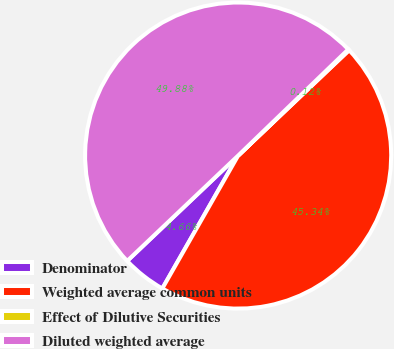Convert chart. <chart><loc_0><loc_0><loc_500><loc_500><pie_chart><fcel>Denominator<fcel>Weighted average common units<fcel>Effect of Dilutive Securities<fcel>Diluted weighted average<nl><fcel>4.66%<fcel>45.34%<fcel>0.12%<fcel>49.88%<nl></chart> 